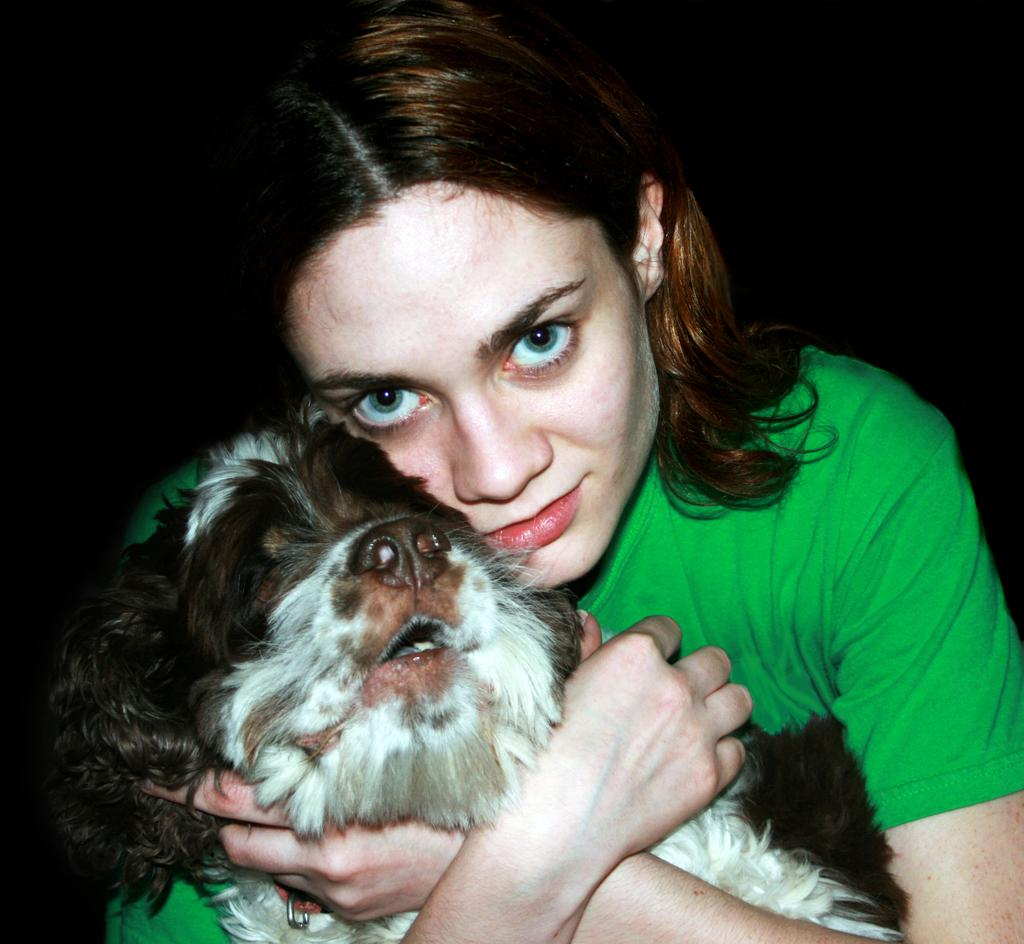Who is the main subject in the image? There is a lady in the image. What is the lady holding in the image? The lady is holding a dog. Can you describe the background of the image? The background of the image is dark. What type of spy equipment can be seen in the lady's hand in the image? There is no spy equipment visible in the lady's hand in the image; she is holding a dog. 